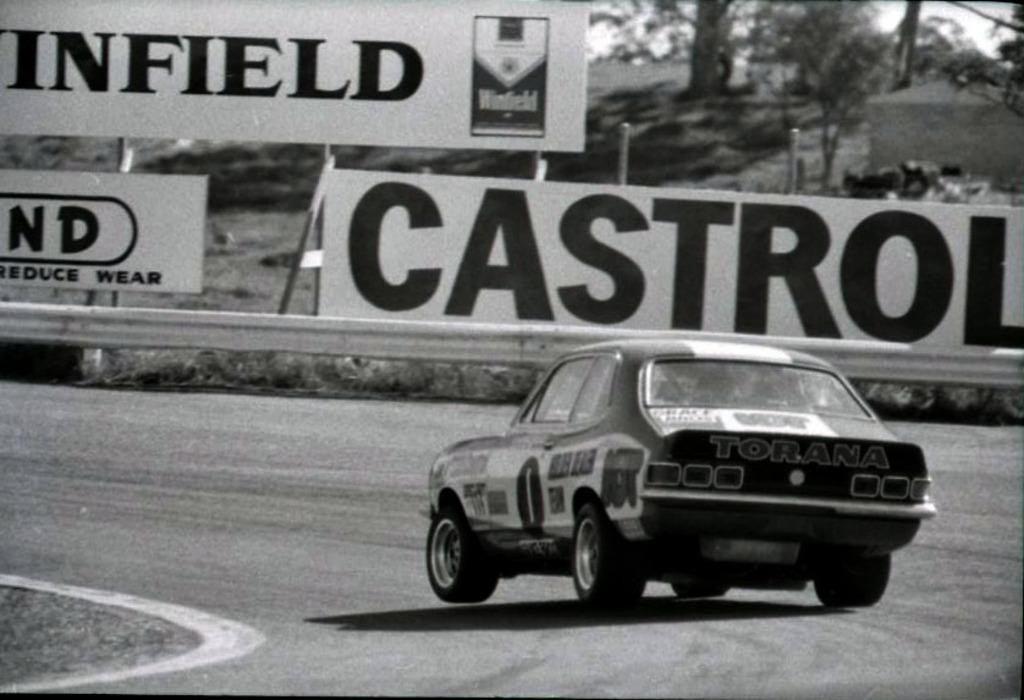What is the color scheme of the image? The image is black and white. What can be seen on the road in the image? There is a car on the road in the image. What is written on the boards in the background? The boards in the background have text on them. What type of vegetation is visible at the top of the image? Trees are visible at the top of the image. Can you see any jellyfish swimming in the water in the image? There is no water or jellyfish present in the image; it features a black and white scene with a car on the road, boards with text, and trees. 